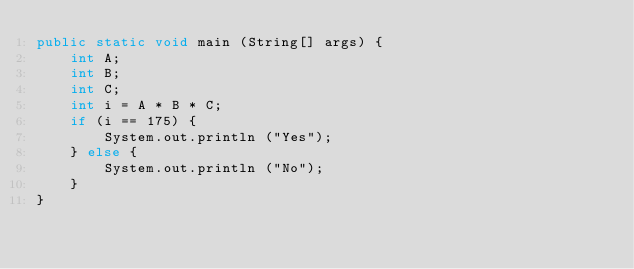<code> <loc_0><loc_0><loc_500><loc_500><_Java_>public static void main (String[] args) {
	int A;
	int B;
	int C;
	int i = A * B * C;
	if (i == 175) {
		System.out.println ("Yes");
	} else {
		System.out.println ("No");
	}
}</code> 